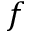Convert formula to latex. <formula><loc_0><loc_0><loc_500><loc_500>f</formula> 